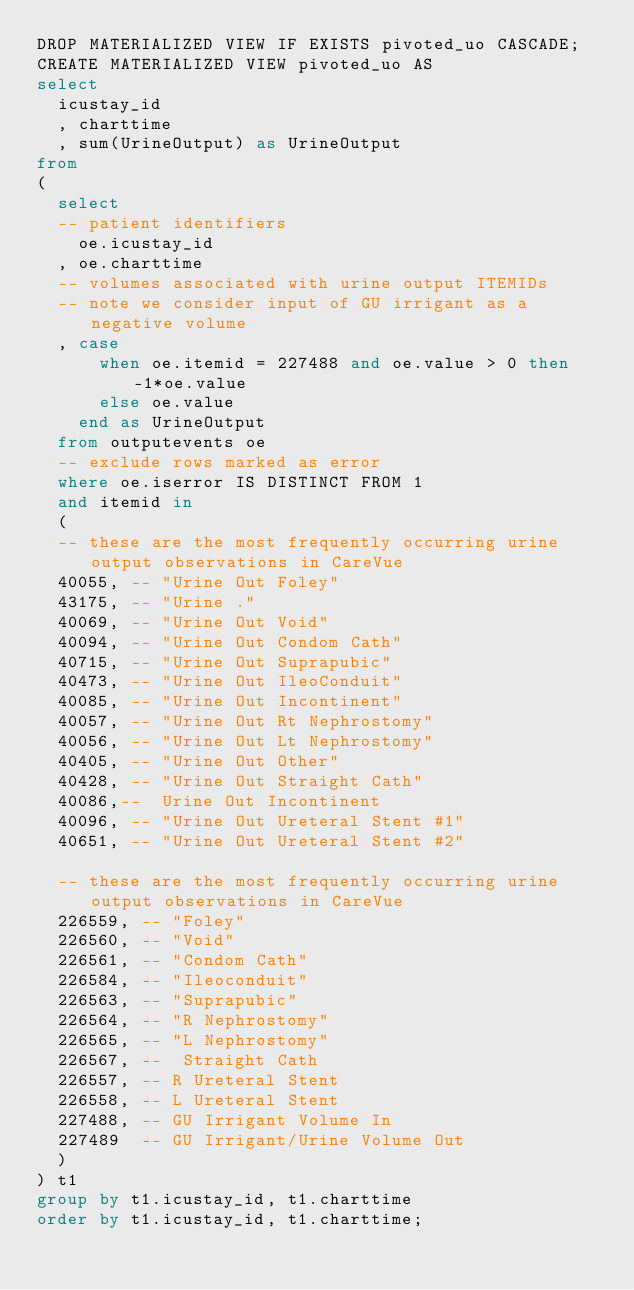Convert code to text. <code><loc_0><loc_0><loc_500><loc_500><_SQL_>DROP MATERIALIZED VIEW IF EXISTS pivoted_uo CASCADE;
CREATE MATERIALIZED VIEW pivoted_uo AS
select
  icustay_id
  , charttime
  , sum(UrineOutput) as UrineOutput
from
(
  select
  -- patient identifiers
    oe.icustay_id
  , oe.charttime
  -- volumes associated with urine output ITEMIDs
  -- note we consider input of GU irrigant as a negative volume
  , case
      when oe.itemid = 227488 and oe.value > 0 then -1*oe.value
      else oe.value
    end as UrineOutput
  from outputevents oe
  -- exclude rows marked as error
  where oe.iserror IS DISTINCT FROM 1
  and itemid in
  (
  -- these are the most frequently occurring urine output observations in CareVue
  40055, -- "Urine Out Foley"
  43175, -- "Urine ."
  40069, -- "Urine Out Void"
  40094, -- "Urine Out Condom Cath"
  40715, -- "Urine Out Suprapubic"
  40473, -- "Urine Out IleoConduit"
  40085, -- "Urine Out Incontinent"
  40057, -- "Urine Out Rt Nephrostomy"
  40056, -- "Urine Out Lt Nephrostomy"
  40405, -- "Urine Out Other"
  40428, -- "Urine Out Straight Cath"
  40086,--	Urine Out Incontinent
  40096, -- "Urine Out Ureteral Stent #1"
  40651, -- "Urine Out Ureteral Stent #2"

  -- these are the most frequently occurring urine output observations in CareVue
  226559, -- "Foley"
  226560, -- "Void"
  226561, -- "Condom Cath"
  226584, -- "Ileoconduit"
  226563, -- "Suprapubic"
  226564, -- "R Nephrostomy"
  226565, -- "L Nephrostomy"
  226567, --	Straight Cath
  226557, -- R Ureteral Stent
  226558, -- L Ureteral Stent
  227488, -- GU Irrigant Volume In
  227489  -- GU Irrigant/Urine Volume Out
  )
) t1
group by t1.icustay_id, t1.charttime
order by t1.icustay_id, t1.charttime;
</code> 